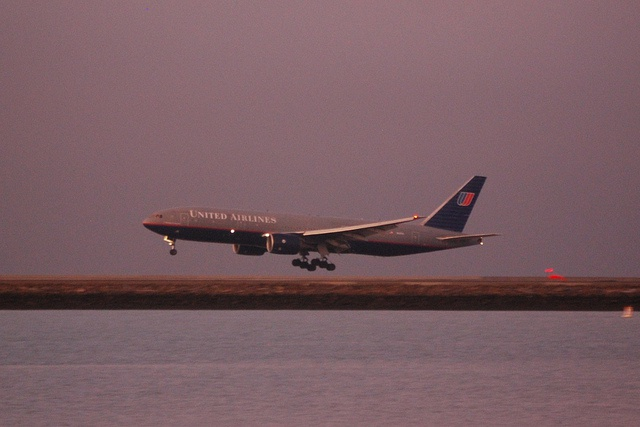Describe the objects in this image and their specific colors. I can see a airplane in gray, black, brown, and maroon tones in this image. 